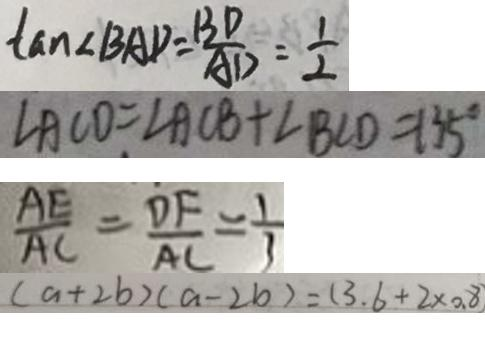<formula> <loc_0><loc_0><loc_500><loc_500>\tan \angle B A D = \frac { B D } { A D } = \frac { 1 } { 2 } 
 \angle A C D = \angle A C B + \angle B C D = 1 3 5 ^ { \circ } 
 \frac { A E } { A C } = \frac { D F } { A C } = \frac { 1 } { 3 } 
 ( a + 2 b ) ( a - 2 b ) = ( 3 . 6 + 2 \times 0 . 8</formula> 